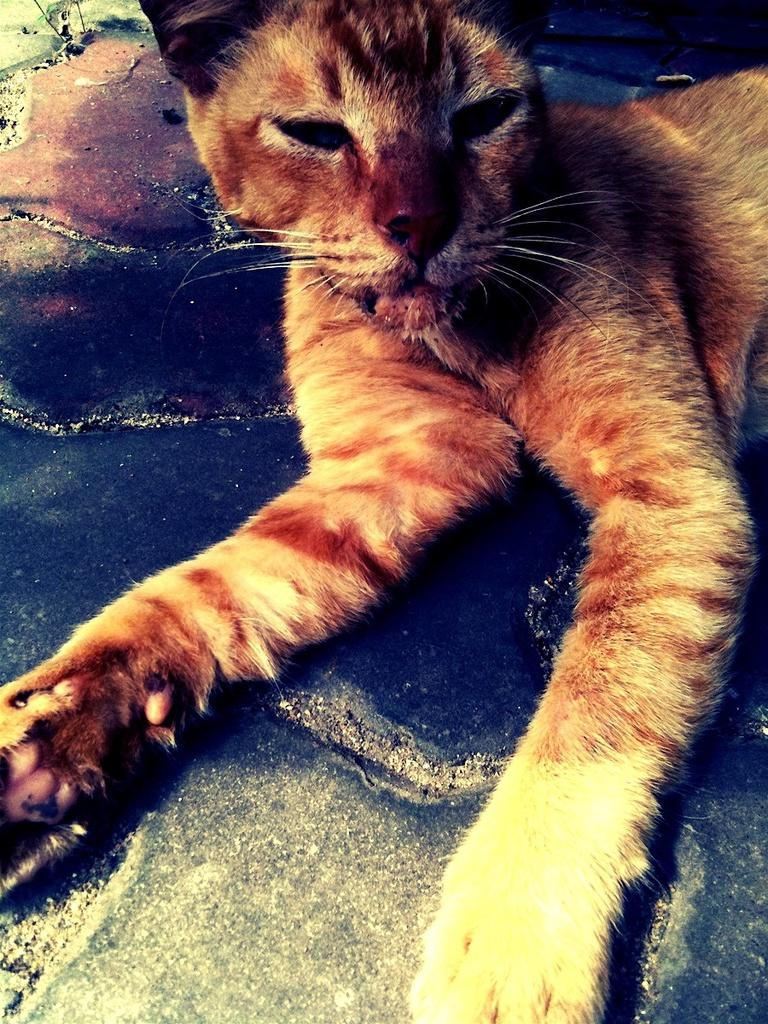What type of animal is in the image? There is a cat in the image. Where is the cat located in the image? The cat is on the floor. What color is the cat in the image? The cat is brown in color. How many children are playing with the cat in the image? There are no children present in the image; it only features a cat on the floor. What type of light source is illuminating the cat in the image? There is no specific light source mentioned or visible in the image; it only shows a brown cat on the floor. 